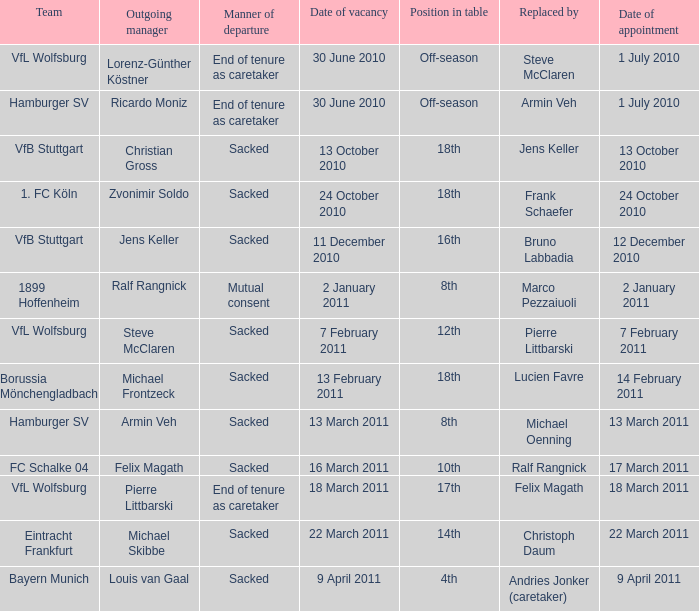When 1. fc köln is the team what is the date of appointment? 24 October 2010. 